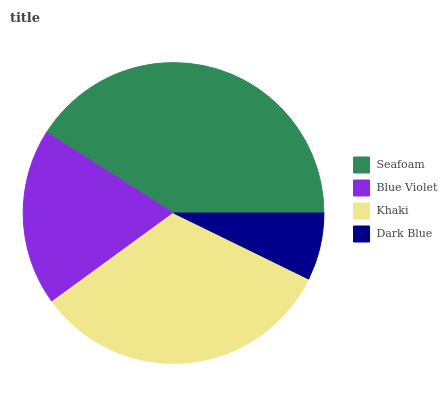Is Dark Blue the minimum?
Answer yes or no. Yes. Is Seafoam the maximum?
Answer yes or no. Yes. Is Blue Violet the minimum?
Answer yes or no. No. Is Blue Violet the maximum?
Answer yes or no. No. Is Seafoam greater than Blue Violet?
Answer yes or no. Yes. Is Blue Violet less than Seafoam?
Answer yes or no. Yes. Is Blue Violet greater than Seafoam?
Answer yes or no. No. Is Seafoam less than Blue Violet?
Answer yes or no. No. Is Khaki the high median?
Answer yes or no. Yes. Is Blue Violet the low median?
Answer yes or no. Yes. Is Blue Violet the high median?
Answer yes or no. No. Is Seafoam the low median?
Answer yes or no. No. 